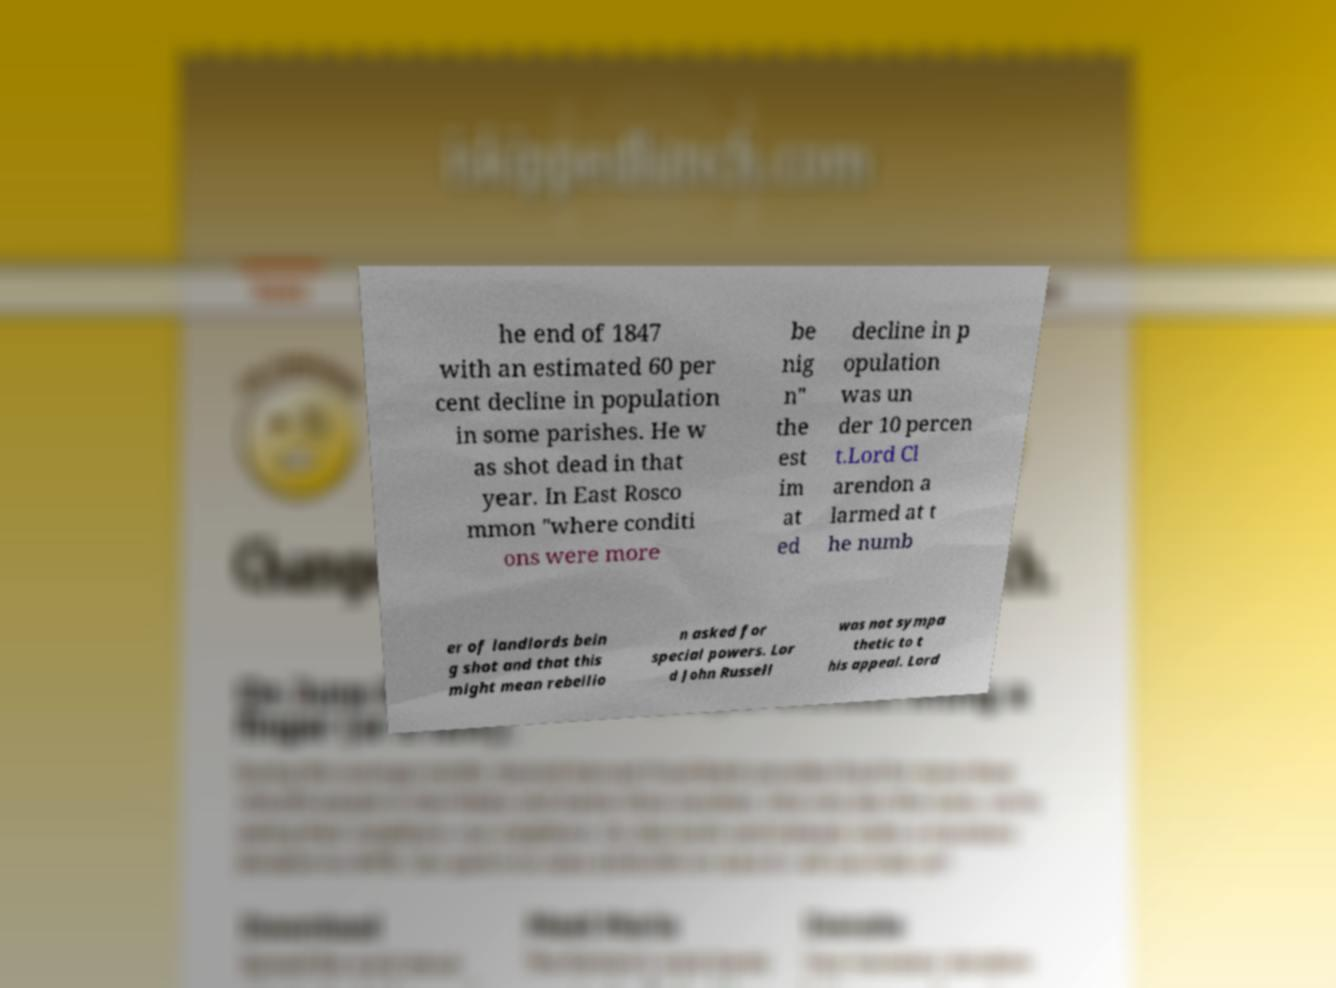I need the written content from this picture converted into text. Can you do that? he end of 1847 with an estimated 60 per cent decline in population in some parishes. He w as shot dead in that year. In East Rosco mmon "where conditi ons were more be nig n" the est im at ed decline in p opulation was un der 10 percen t.Lord Cl arendon a larmed at t he numb er of landlords bein g shot and that this might mean rebellio n asked for special powers. Lor d John Russell was not sympa thetic to t his appeal. Lord 